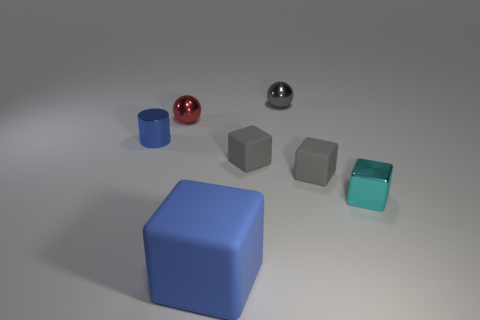Subtract all green balls. How many gray cubes are left? 2 Add 3 small shiny balls. How many objects exist? 10 Subtract all cyan blocks. How many blocks are left? 3 Subtract 1 cubes. How many cubes are left? 3 Subtract all cyan blocks. How many blocks are left? 3 Subtract all purple cubes. Subtract all cyan cylinders. How many cubes are left? 4 Subtract all spheres. How many objects are left? 5 Add 3 large purple rubber blocks. How many large purple rubber blocks exist? 3 Subtract 1 cyan blocks. How many objects are left? 6 Subtract all big rubber blocks. Subtract all small blue matte blocks. How many objects are left? 6 